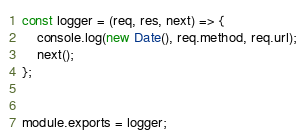Convert code to text. <code><loc_0><loc_0><loc_500><loc_500><_JavaScript_>
const logger = (req, res, next) => {
    console.log(new Date(), req.method, req.url);
    next();
};
 

module.exports = logger;
</code> 